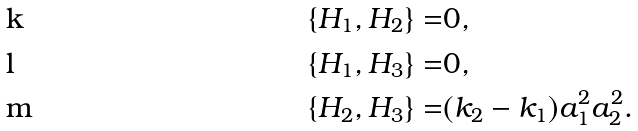<formula> <loc_0><loc_0><loc_500><loc_500>\{ H _ { 1 } , H _ { 2 } \} = & 0 , \\ \{ H _ { 1 } , H _ { 3 } \} = & 0 , \\ \{ H _ { 2 } , H _ { 3 } \} = & ( k _ { 2 } - k _ { 1 } ) a _ { 1 } ^ { 2 } a _ { 2 } ^ { 2 } .</formula> 